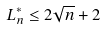<formula> <loc_0><loc_0><loc_500><loc_500>L _ { n } ^ { * } \leq 2 \sqrt { n } + 2</formula> 